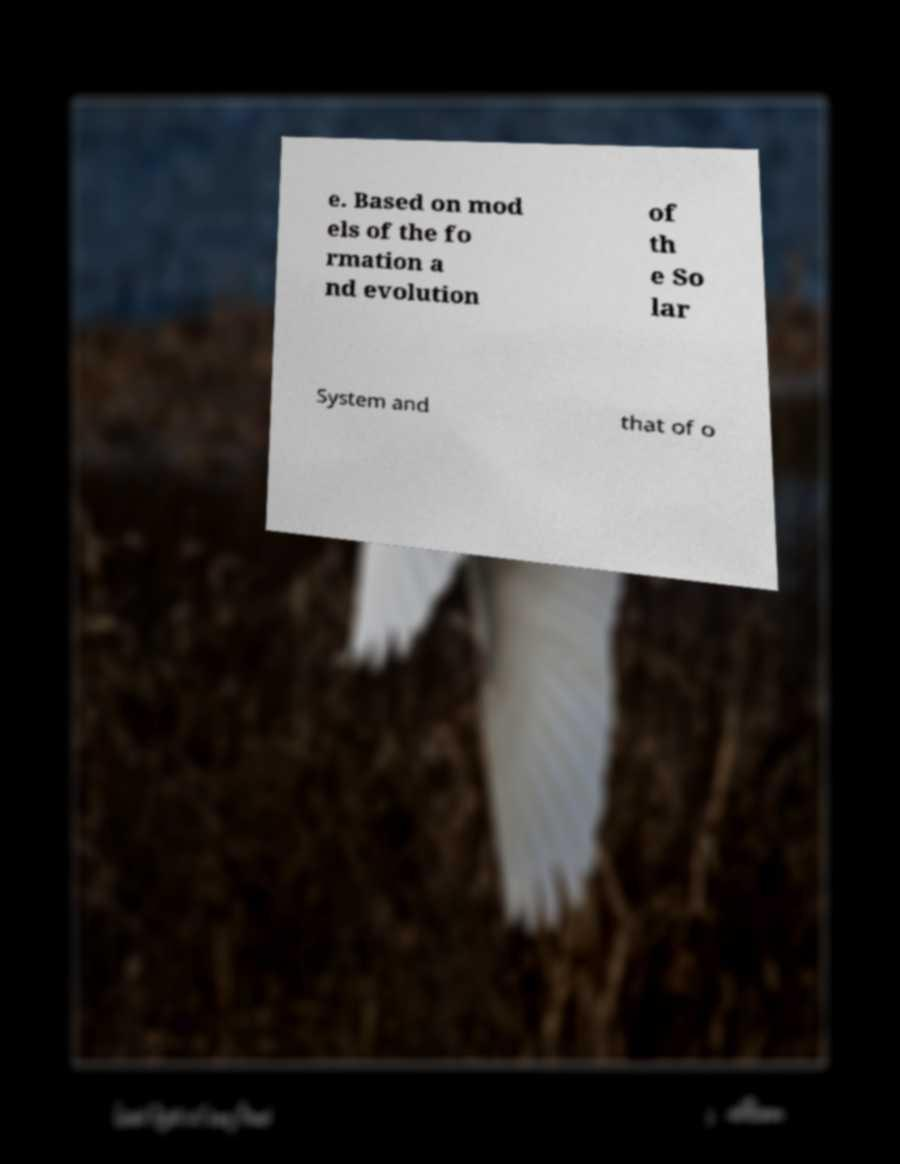Can you read and provide the text displayed in the image?This photo seems to have some interesting text. Can you extract and type it out for me? e. Based on mod els of the fo rmation a nd evolution of th e So lar System and that of o 